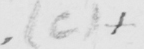What text is written in this handwritten line? ( c )   + 